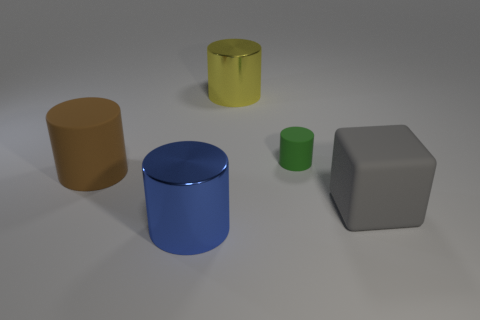Is the number of metallic cylinders less than the number of large green cylinders? Yes, there is only one metallic-looking cylinder which is less than the number of large green cylinders, as there are two green cylinders, one large and one small. 